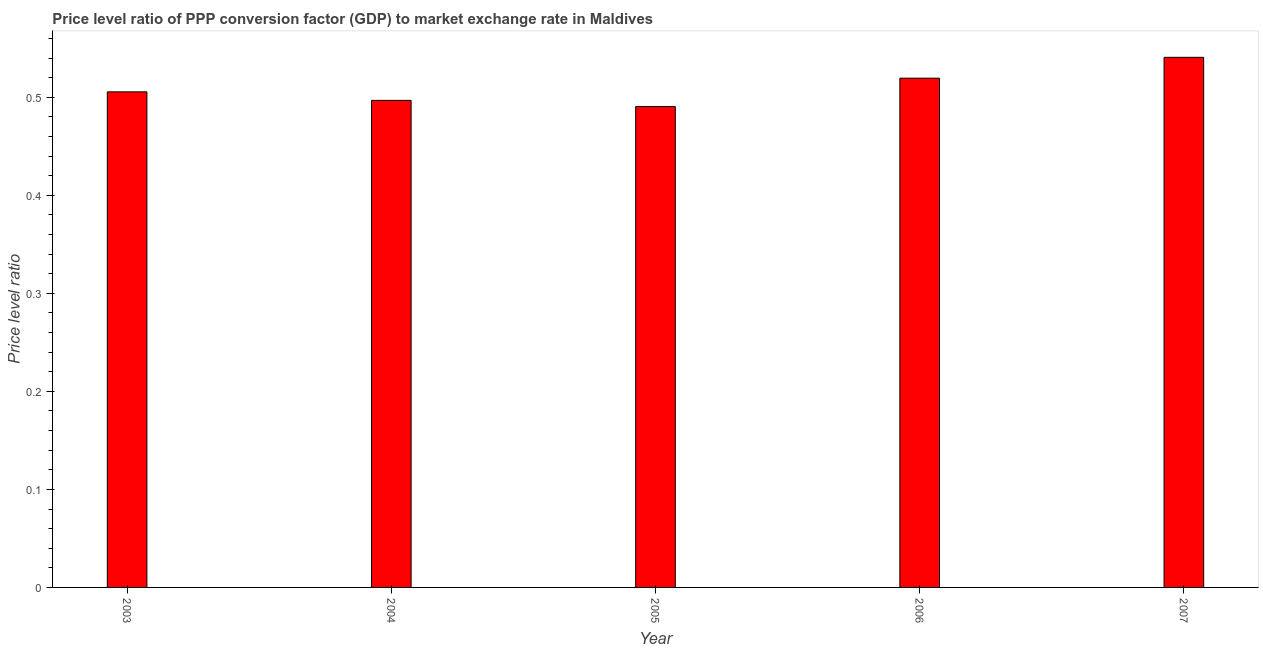Does the graph contain any zero values?
Ensure brevity in your answer.  No. Does the graph contain grids?
Provide a short and direct response. No. What is the title of the graph?
Offer a very short reply. Price level ratio of PPP conversion factor (GDP) to market exchange rate in Maldives. What is the label or title of the X-axis?
Keep it short and to the point. Year. What is the label or title of the Y-axis?
Provide a succinct answer. Price level ratio. What is the price level ratio in 2005?
Provide a succinct answer. 0.49. Across all years, what is the maximum price level ratio?
Your response must be concise. 0.54. Across all years, what is the minimum price level ratio?
Your answer should be very brief. 0.49. What is the sum of the price level ratio?
Keep it short and to the point. 2.55. What is the difference between the price level ratio in 2003 and 2004?
Provide a short and direct response. 0.01. What is the average price level ratio per year?
Provide a short and direct response. 0.51. What is the median price level ratio?
Provide a short and direct response. 0.51. In how many years, is the price level ratio greater than 0.24 ?
Keep it short and to the point. 5. Is the price level ratio in 2003 less than that in 2005?
Offer a terse response. No. Is the difference between the price level ratio in 2004 and 2007 greater than the difference between any two years?
Make the answer very short. No. What is the difference between the highest and the second highest price level ratio?
Your answer should be compact. 0.02. Is the sum of the price level ratio in 2003 and 2007 greater than the maximum price level ratio across all years?
Your response must be concise. Yes. Are all the bars in the graph horizontal?
Give a very brief answer. No. What is the difference between two consecutive major ticks on the Y-axis?
Offer a terse response. 0.1. What is the Price level ratio in 2003?
Ensure brevity in your answer.  0.51. What is the Price level ratio of 2004?
Ensure brevity in your answer.  0.5. What is the Price level ratio of 2005?
Offer a terse response. 0.49. What is the Price level ratio in 2006?
Provide a succinct answer. 0.52. What is the Price level ratio in 2007?
Offer a terse response. 0.54. What is the difference between the Price level ratio in 2003 and 2004?
Make the answer very short. 0.01. What is the difference between the Price level ratio in 2003 and 2005?
Give a very brief answer. 0.01. What is the difference between the Price level ratio in 2003 and 2006?
Make the answer very short. -0.01. What is the difference between the Price level ratio in 2003 and 2007?
Your response must be concise. -0.04. What is the difference between the Price level ratio in 2004 and 2005?
Your response must be concise. 0.01. What is the difference between the Price level ratio in 2004 and 2006?
Offer a terse response. -0.02. What is the difference between the Price level ratio in 2004 and 2007?
Provide a short and direct response. -0.04. What is the difference between the Price level ratio in 2005 and 2006?
Offer a very short reply. -0.03. What is the difference between the Price level ratio in 2005 and 2007?
Your answer should be compact. -0.05. What is the difference between the Price level ratio in 2006 and 2007?
Offer a terse response. -0.02. What is the ratio of the Price level ratio in 2003 to that in 2005?
Your answer should be very brief. 1.03. What is the ratio of the Price level ratio in 2003 to that in 2007?
Provide a short and direct response. 0.94. What is the ratio of the Price level ratio in 2004 to that in 2005?
Your answer should be compact. 1.01. What is the ratio of the Price level ratio in 2004 to that in 2006?
Your answer should be compact. 0.96. What is the ratio of the Price level ratio in 2004 to that in 2007?
Provide a succinct answer. 0.92. What is the ratio of the Price level ratio in 2005 to that in 2006?
Your answer should be very brief. 0.94. What is the ratio of the Price level ratio in 2005 to that in 2007?
Your response must be concise. 0.91. What is the ratio of the Price level ratio in 2006 to that in 2007?
Ensure brevity in your answer.  0.96. 